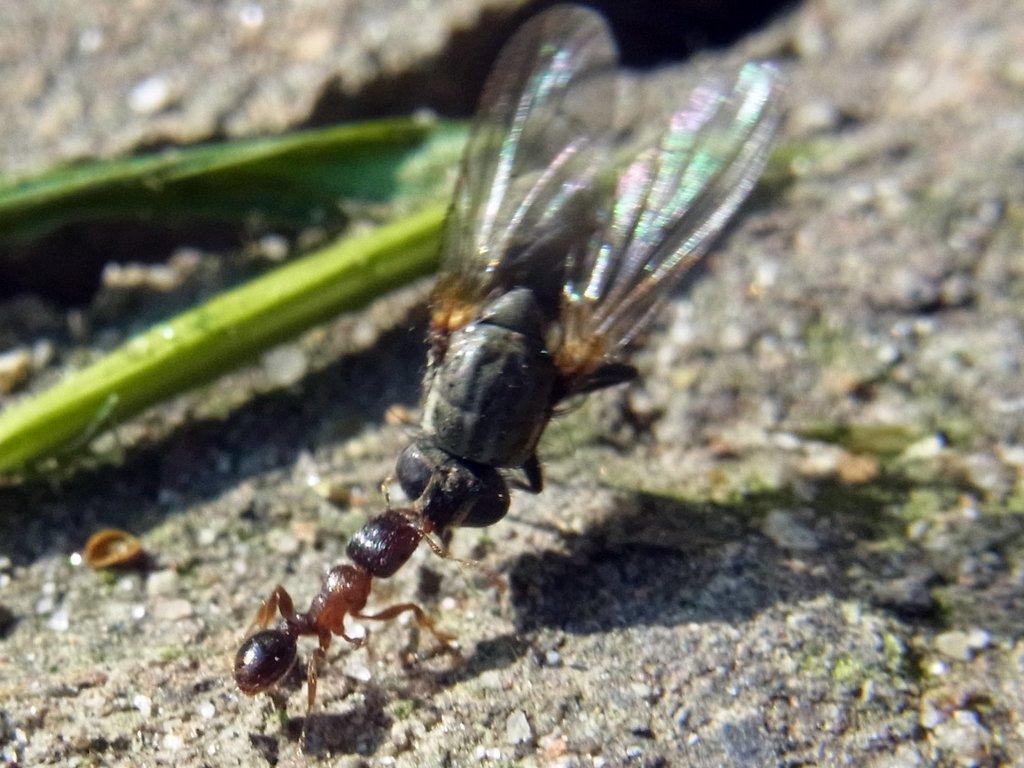Can you describe this image briefly? In the image there is an ant and a house fly on the ground. And also there is a green color item on the ground. 